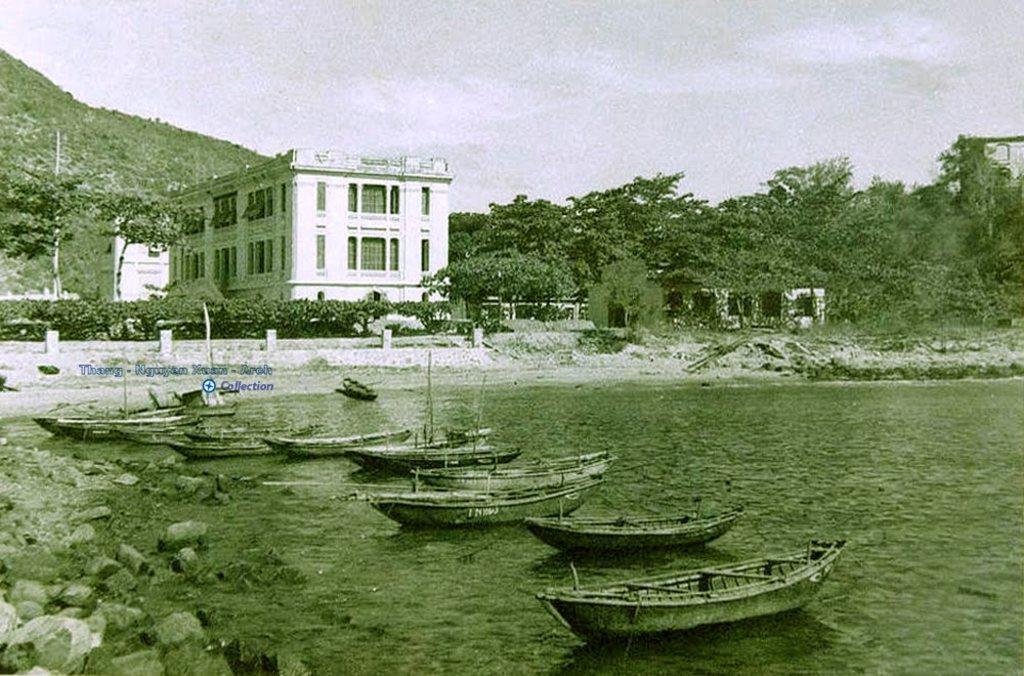Can you describe this image briefly? In this image there are rocks, water,boats, buildings, trees, hill, sky and objects. On the image there is a watermark. 